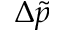Convert formula to latex. <formula><loc_0><loc_0><loc_500><loc_500>\Delta \tilde { p }</formula> 